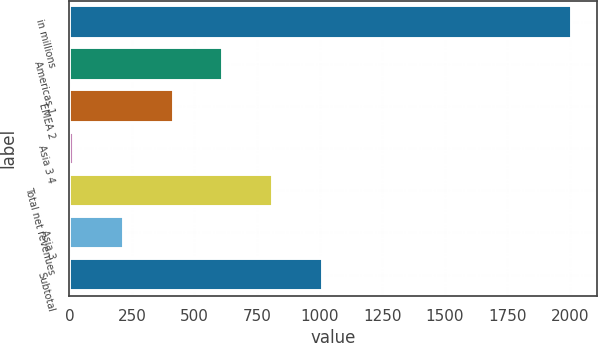Convert chart. <chart><loc_0><loc_0><loc_500><loc_500><bar_chart><fcel>in millions<fcel>Americas 1<fcel>EMEA 2<fcel>Asia 3 4<fcel>Total net revenues<fcel>Asia 3<fcel>Subtotal<nl><fcel>2010<fcel>615.6<fcel>416.4<fcel>18<fcel>814.8<fcel>217.2<fcel>1014<nl></chart> 